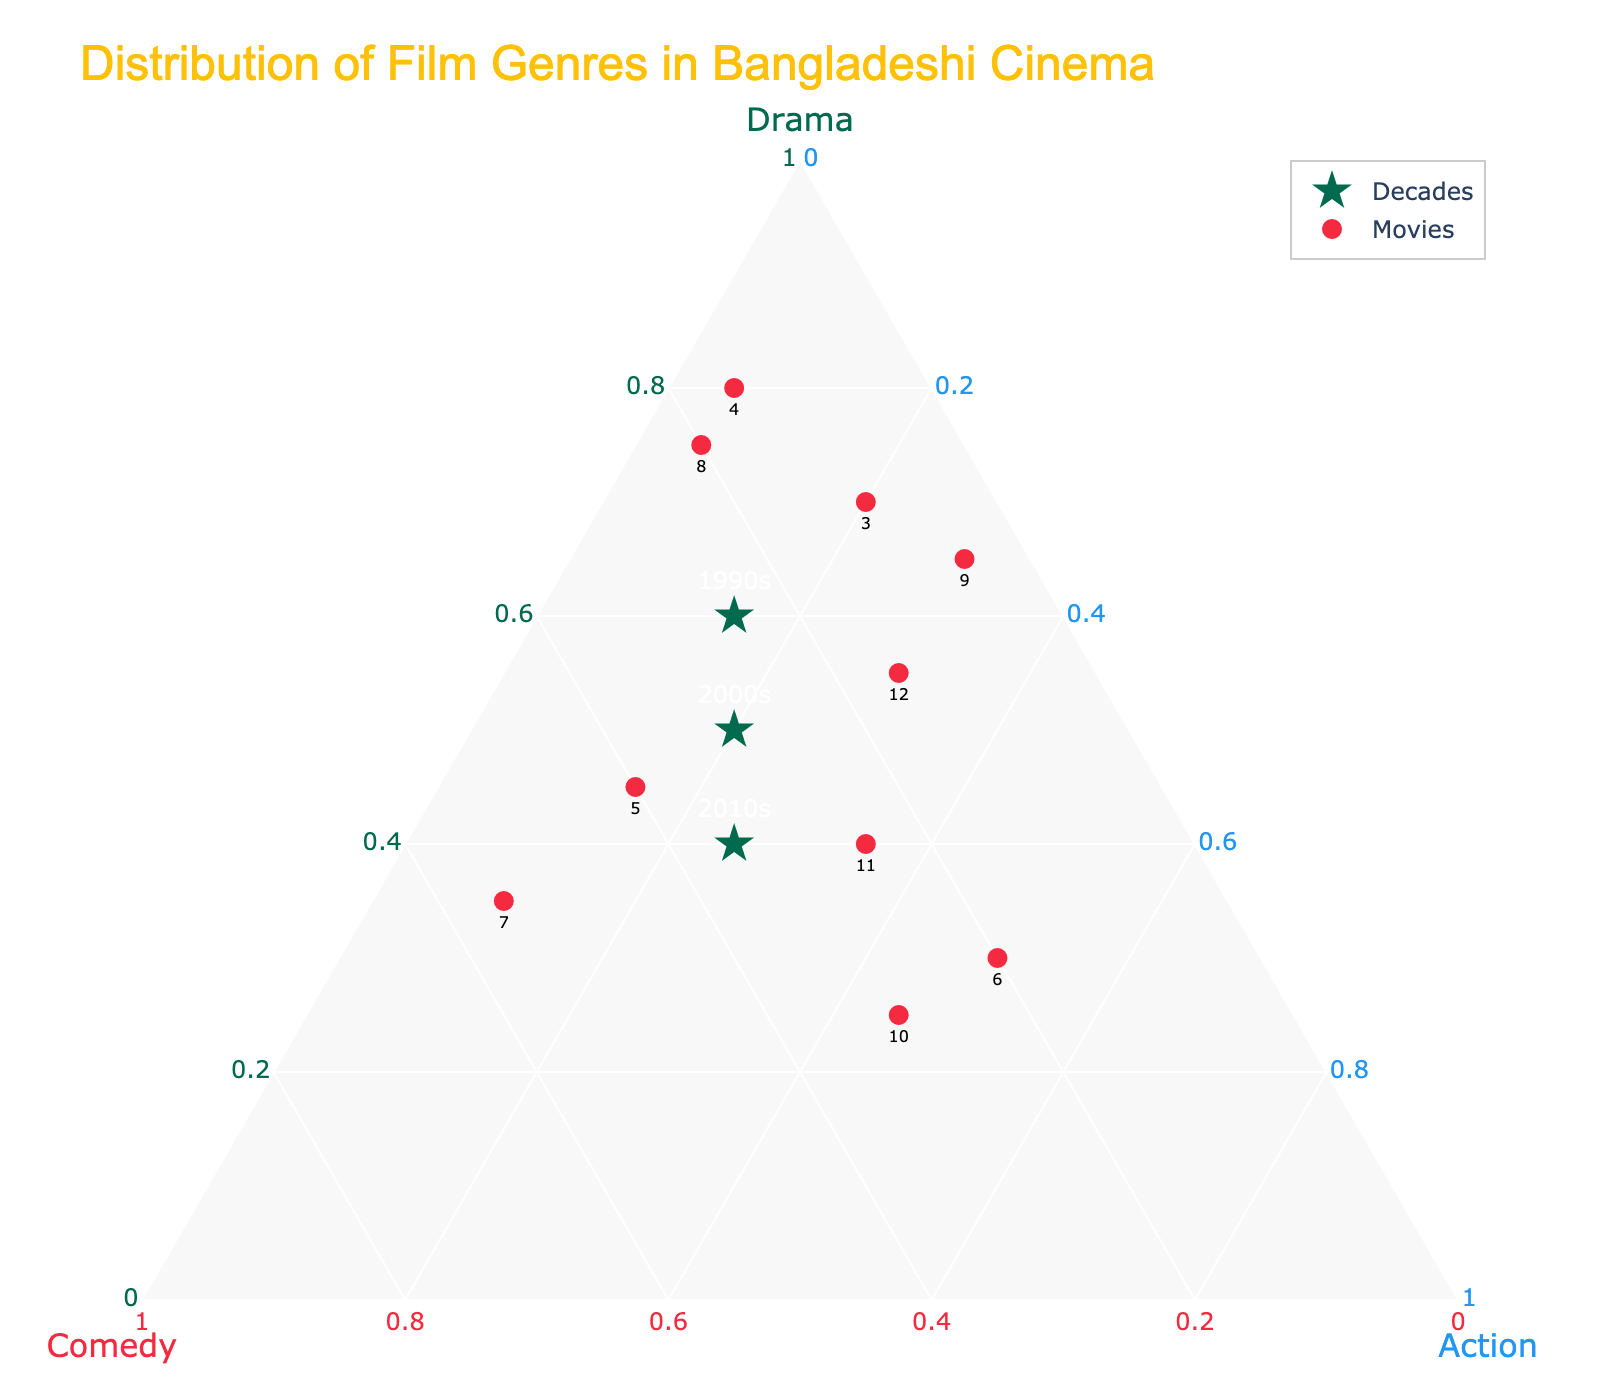Which decade has the highest proportion of Drama films? Look at the ternary plot and identify which decade's marker is closest to the Drama axis. The 1990s have the highest percentage of 60% for Drama.
Answer: 1990s How does the distribution of film genres in Mukti Juddher Golpo compare to the 2000s? Mukti Juddher Golpo has 70% Drama, 10% Comedy, and 20% Action. The 2000s have 50% Drama, 30% Comedy, and 20% Action. Mukti Juddher Golpo has more Drama but less Comedy compared to the 2000s. Action percentages are the same.
Answer: More Drama, less Comedy, same Action Which movie emphasizes Comedy the most? Observe the plot and find the movie marker closest to the Comedy axis. Television stands out with 55% Comedy.
Answer: Television What is the combined proportion of Comedy and Action in Film 'Dhaka Attack'? Add up the genres for Dhaka Attack: Comedy (20%) + Action (50%) = 70%.
Answer: 70% From the 2010s to which movie is the genre distribution most similar? Compare the plot of the 2010s marker to the other movie plot points. The 2010s have 40% Drama, 35% Comedy, and 25% Action. The closest match is Chorabali with 40% Drama, 25% Comedy, and 35% Action.
Answer: Chorabali Which genre increased consistently over the decades? Compare the decade markers on the ternary plot to see any genre's consistent increase. Comedy increases from the 1990s (25%) to the 2000s (30%) to the 2010s (35%).
Answer: Comedy What are the genre proportions of the movie Debi? Locate the Debi marker on the plot and refer to the axes. Debi has 55% Drama, 15% Comedy, and 30% Action.
Answer: 55% Drama, 15% Comedy, 30% Action Which decade shows a decrease in Drama films? Compare the decade markers. From the 1990s (60%) to the 2000s (50%) and then to the 2010s (40%), Drama consistently decreases.
Answer: 2000s and 2010s How do the genre distributions of Monpura and Third Person Singular Number differ? Check both movie markers' positions on the plot. Monpura has 80% Drama, 15% Comedy, and 5% Action, whereas Third Person Singular Number has 75% Drama, 20% Comedy, and 5% Action.
Answer: Monpura has slightly more Drama; Third Person Singular Number has slightly more Comedy Which movie has the genre distribution closest to the 1990s? Compare the 1990s marker with the movie plot points. The 1990s have 60% Drama, 25% Comedy, and 15% Action. The closest is Aynabaji with 45% Drama, 40% Comedy, and 15% Action.
Answer: Aynabaji 